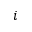<formula> <loc_0><loc_0><loc_500><loc_500>i</formula> 